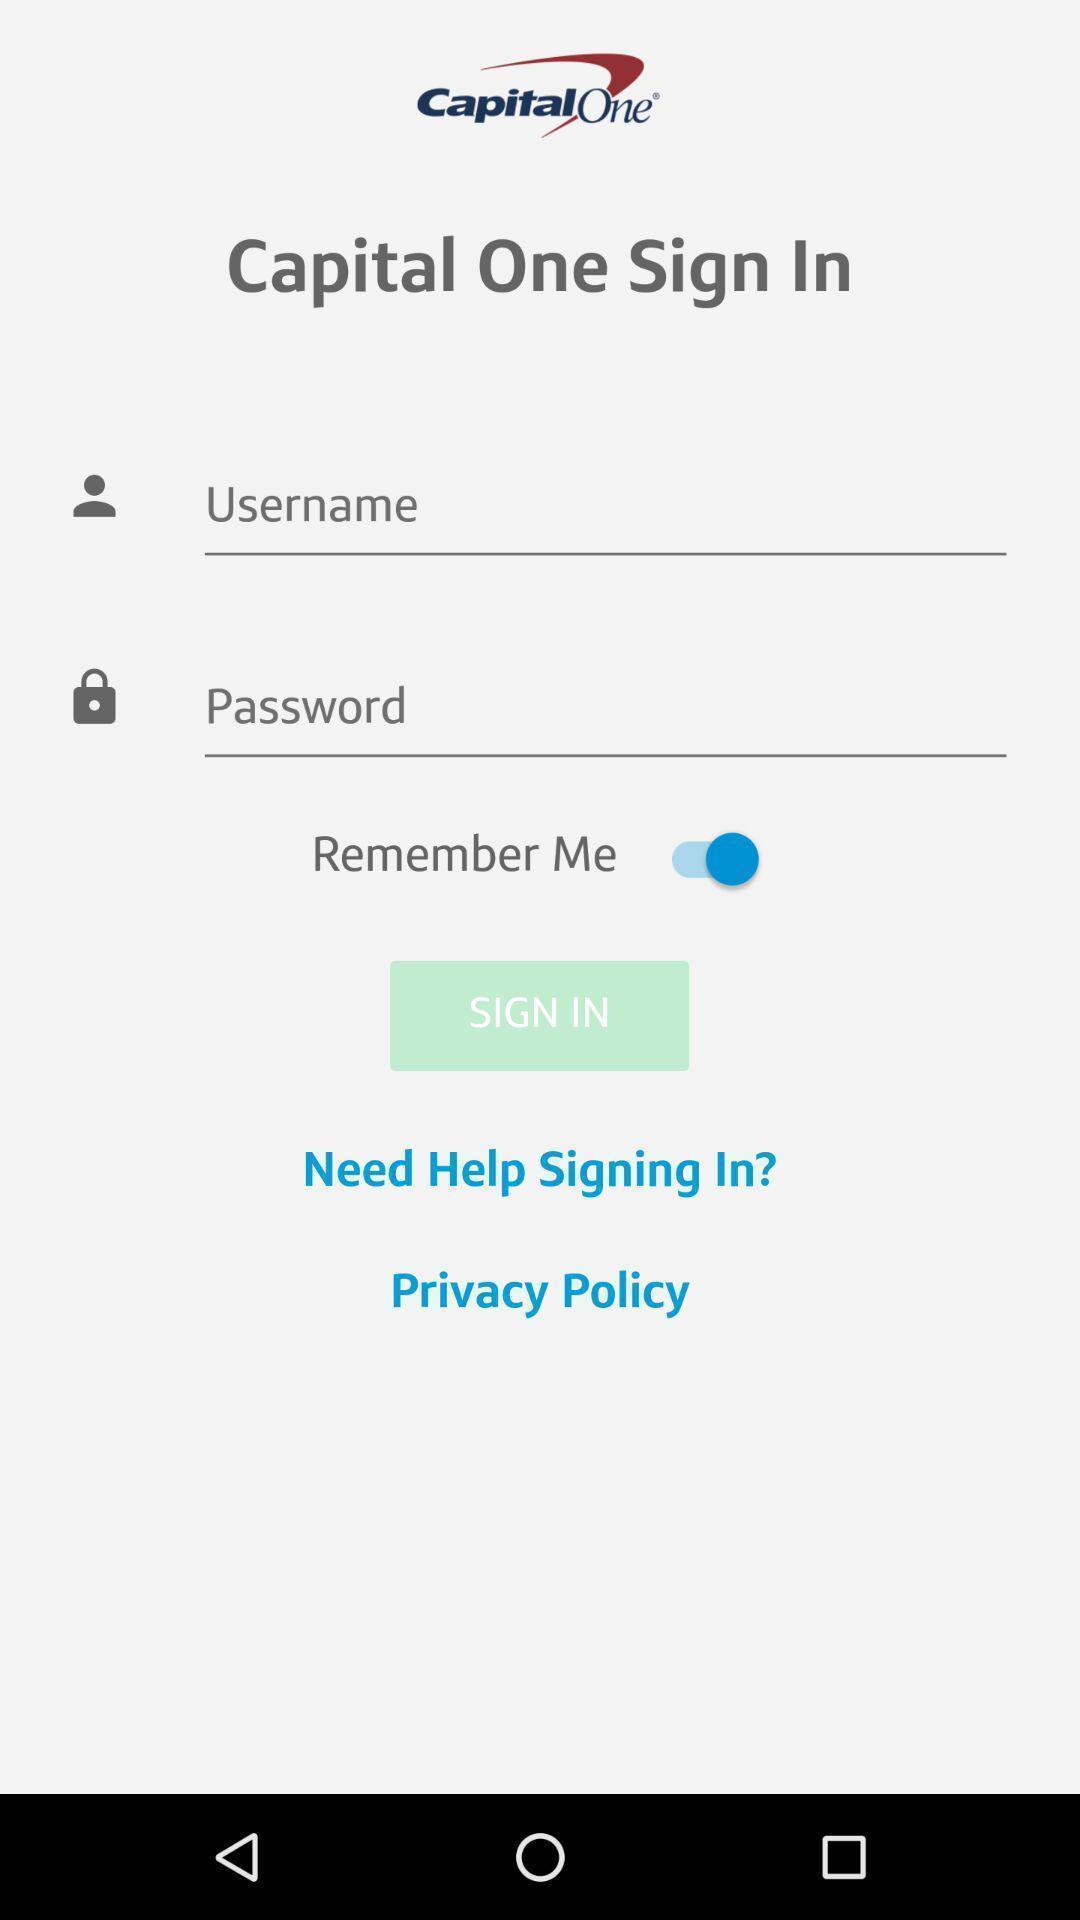What details can you identify in this image? Sign in page of an account. 